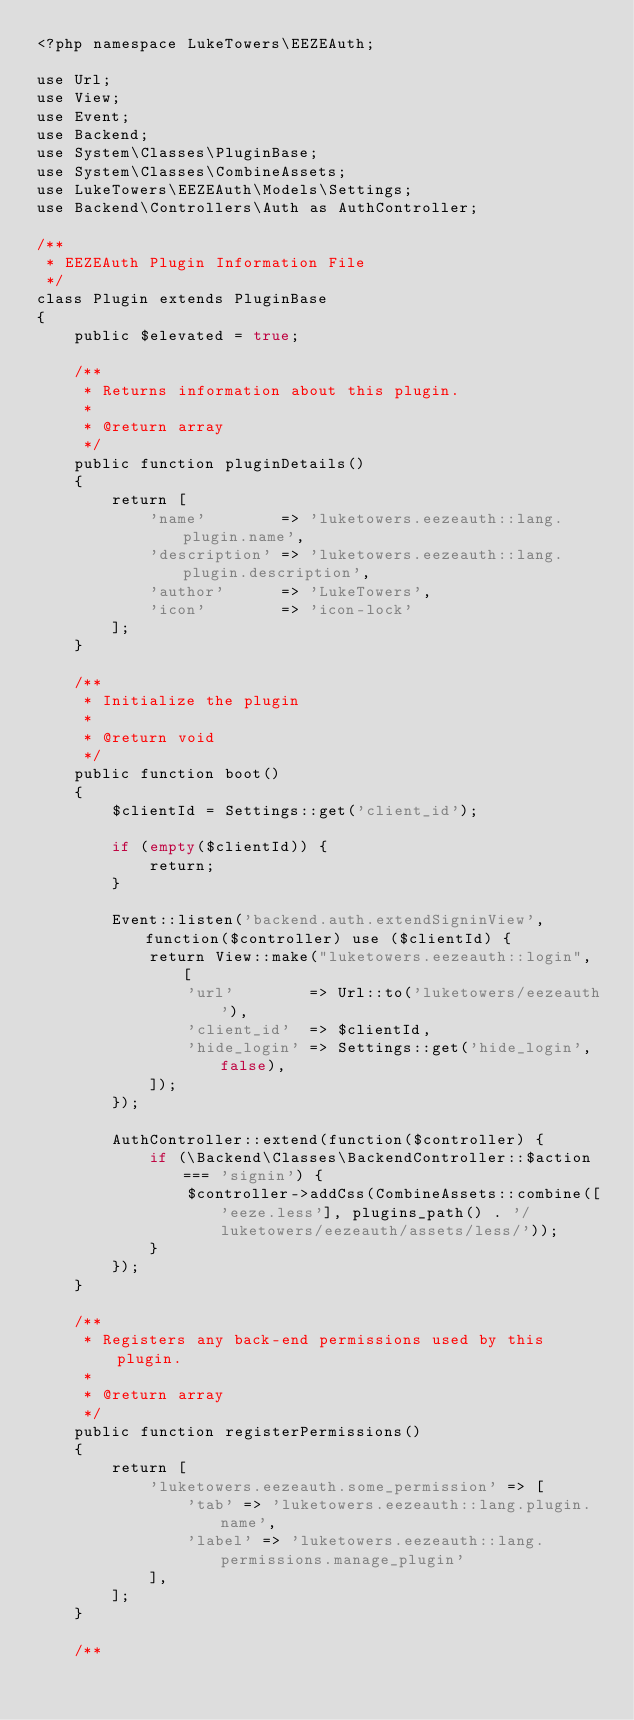<code> <loc_0><loc_0><loc_500><loc_500><_PHP_><?php namespace LukeTowers\EEZEAuth;

use Url;
use View;
use Event;
use Backend;
use System\Classes\PluginBase;
use System\Classes\CombineAssets;
use LukeTowers\EEZEAuth\Models\Settings;
use Backend\Controllers\Auth as AuthController;

/**
 * EEZEAuth Plugin Information File
 */
class Plugin extends PluginBase
{
    public $elevated = true;

    /**
     * Returns information about this plugin.
     *
     * @return array
     */
    public function pluginDetails()
    {
        return [
            'name'        => 'luketowers.eezeauth::lang.plugin.name',
            'description' => 'luketowers.eezeauth::lang.plugin.description',
            'author'      => 'LukeTowers',
            'icon'        => 'icon-lock'
        ];
    }

    /**
     * Initialize the plugin
     *
     * @return void
     */
    public function boot()
    {
        $clientId = Settings::get('client_id');

        if (empty($clientId)) {
            return;
        }

        Event::listen('backend.auth.extendSigninView', function($controller) use ($clientId) {
            return View::make("luketowers.eezeauth::login", [
                'url'        => Url::to('luketowers/eezeauth'),
                'client_id'  => $clientId,
                'hide_login' => Settings::get('hide_login', false),
            ]);
        });

        AuthController::extend(function($controller) {
            if (\Backend\Classes\BackendController::$action === 'signin') {
                $controller->addCss(CombineAssets::combine(['eeze.less'], plugins_path() . '/luketowers/eezeauth/assets/less/'));
            }
        });
    }

    /**
     * Registers any back-end permissions used by this plugin.
     *
     * @return array
     */
    public function registerPermissions()
    {
        return [
            'luketowers.eezeauth.some_permission' => [
                'tab' => 'luketowers.eezeauth::lang.plugin.name',
                'label' => 'luketowers.eezeauth::lang.permissions.manage_plugin'
            ],
        ];
    }

    /**</code> 